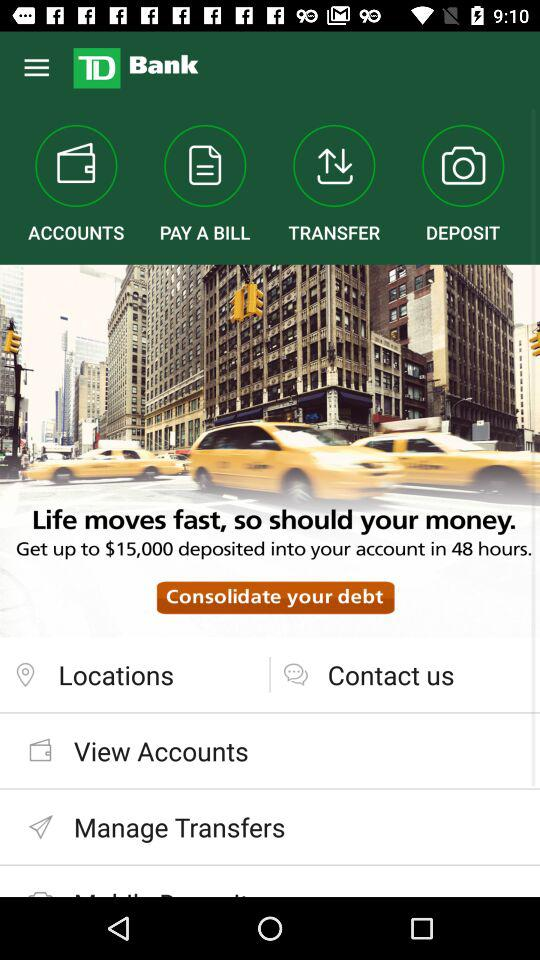What is the name of the application? The name of the application is "TD Bank". 